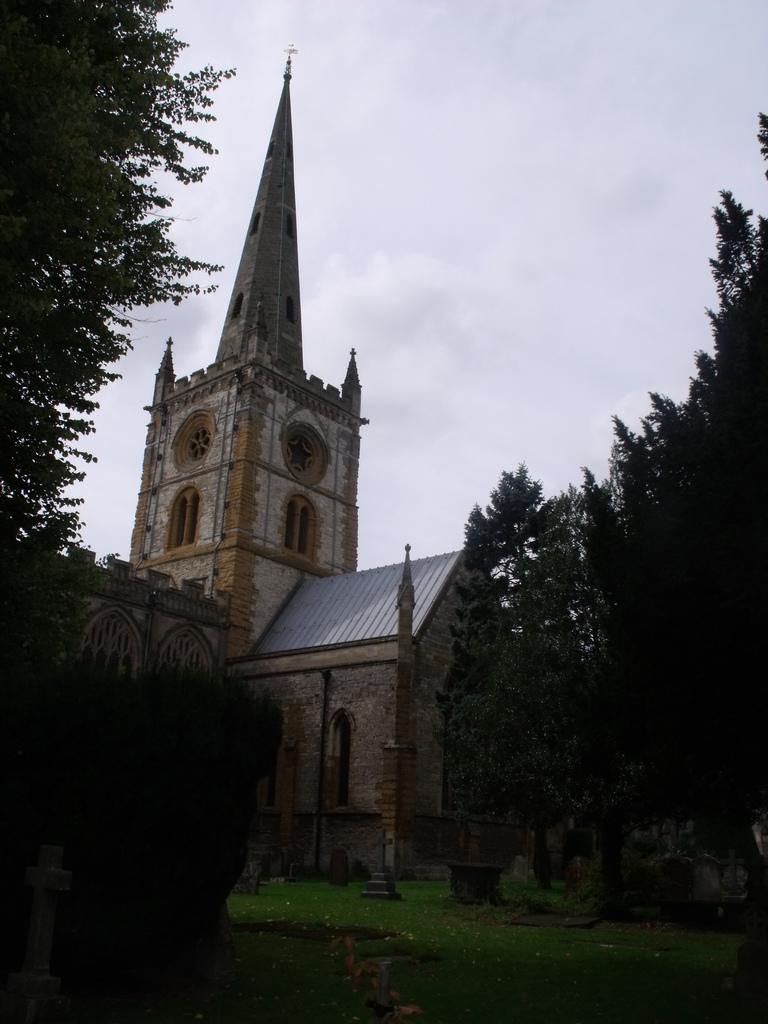Could you give a brief overview of what you see in this image? As we can see in the image there are trees, buildings, grass and sky. 